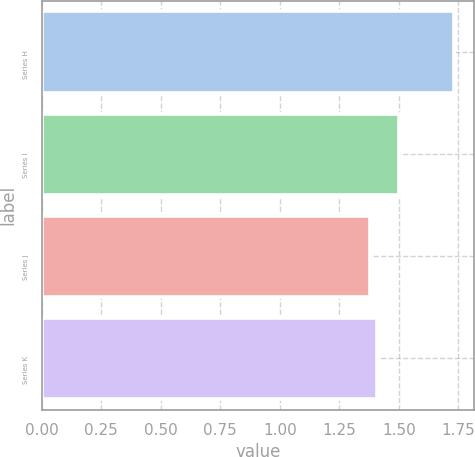<chart> <loc_0><loc_0><loc_500><loc_500><bar_chart><fcel>Series H<fcel>Series I<fcel>Series J<fcel>Series K<nl><fcel>1.73<fcel>1.5<fcel>1.38<fcel>1.41<nl></chart> 